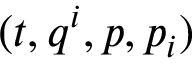<formula> <loc_0><loc_0><loc_500><loc_500>( t , q ^ { i } , p , p _ { i } )</formula> 